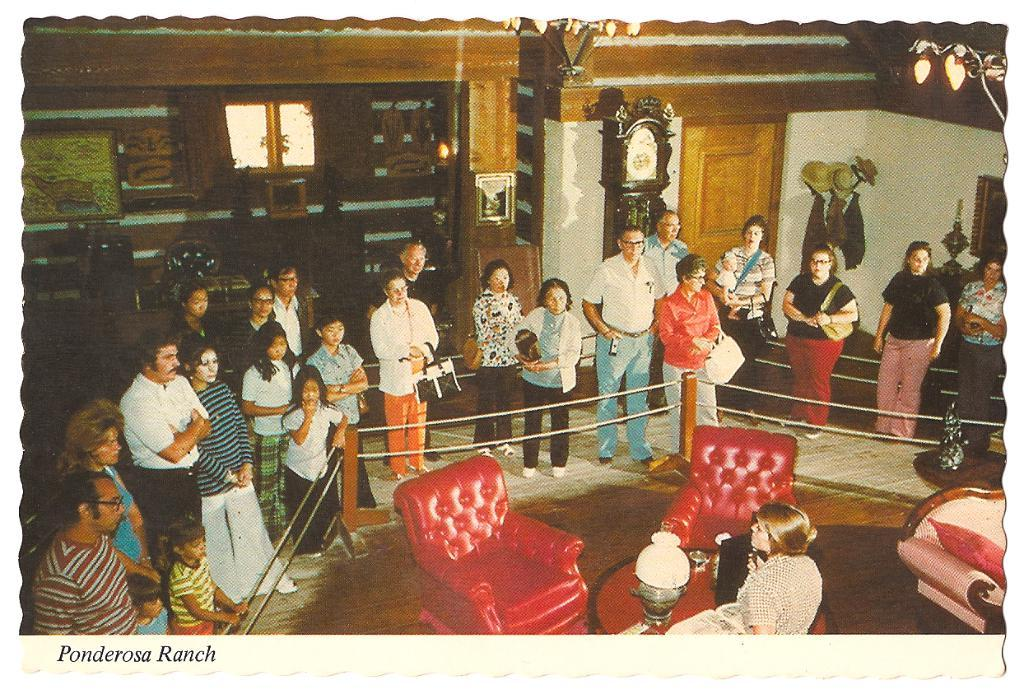<image>
Render a clear and concise summary of the photo. A group gathers to hear remarks by a speaker in a historic house. 